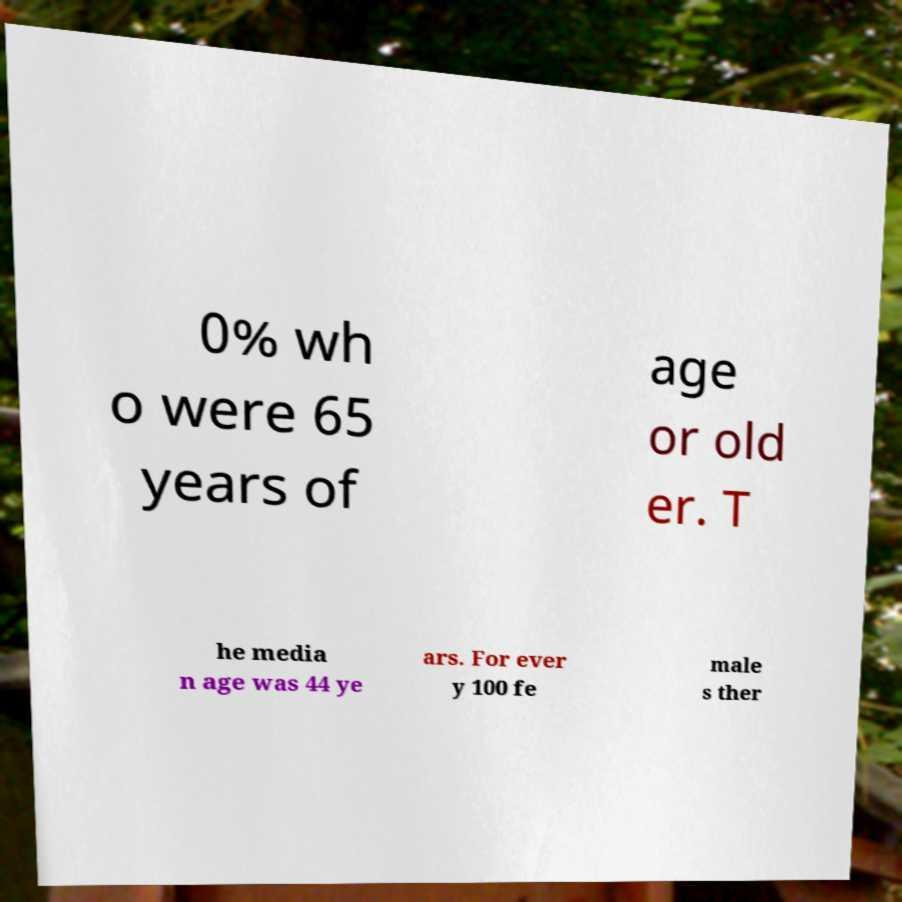For documentation purposes, I need the text within this image transcribed. Could you provide that? 0% wh o were 65 years of age or old er. T he media n age was 44 ye ars. For ever y 100 fe male s ther 